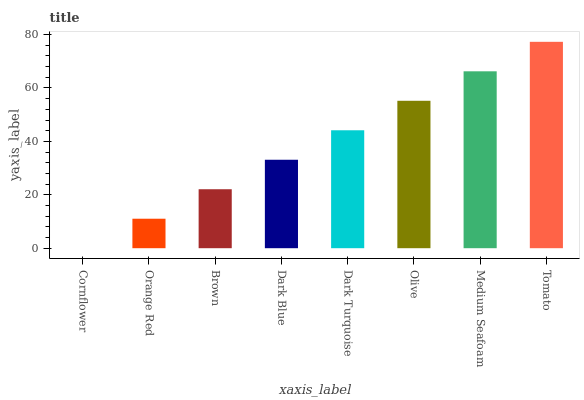Is Cornflower the minimum?
Answer yes or no. Yes. Is Tomato the maximum?
Answer yes or no. Yes. Is Orange Red the minimum?
Answer yes or no. No. Is Orange Red the maximum?
Answer yes or no. No. Is Orange Red greater than Cornflower?
Answer yes or no. Yes. Is Cornflower less than Orange Red?
Answer yes or no. Yes. Is Cornflower greater than Orange Red?
Answer yes or no. No. Is Orange Red less than Cornflower?
Answer yes or no. No. Is Dark Turquoise the high median?
Answer yes or no. Yes. Is Dark Blue the low median?
Answer yes or no. Yes. Is Medium Seafoam the high median?
Answer yes or no. No. Is Orange Red the low median?
Answer yes or no. No. 